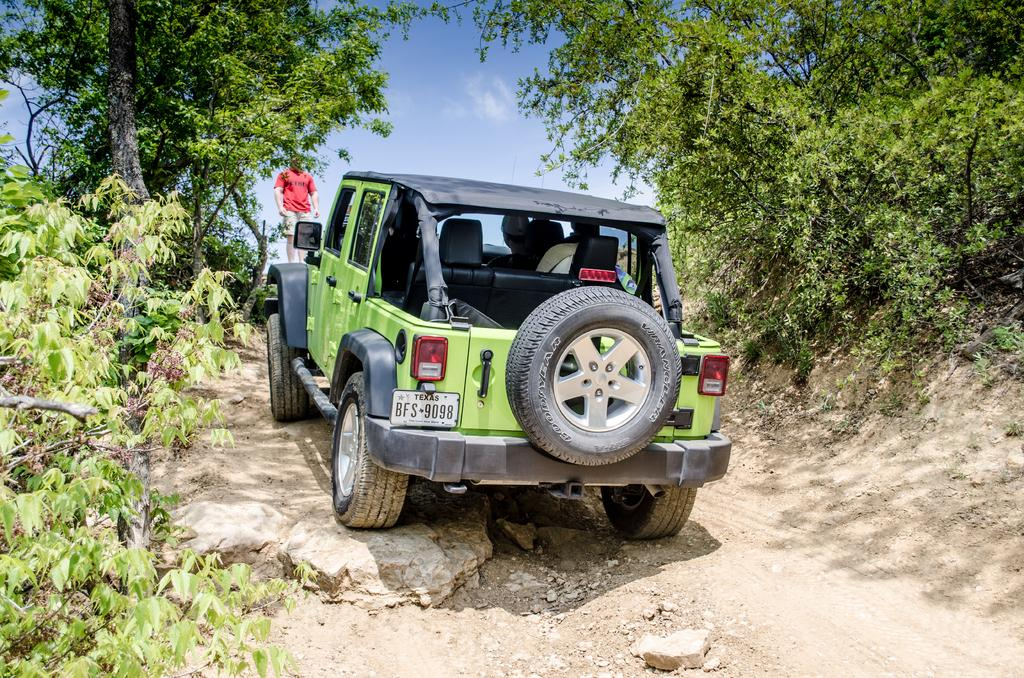What is the main subject in the center of the image? There is a vehicle in the center of the image. Can you describe any other elements in the image? Yes, there is a man standing in the image. What can be seen in the background of the image? There are trees and the sky visible in the background of the image. What type of cake is the man eating while driving the vehicle in the image? There is no cake or driving present in the image. The man is standing, and the vehicle is stationary. 